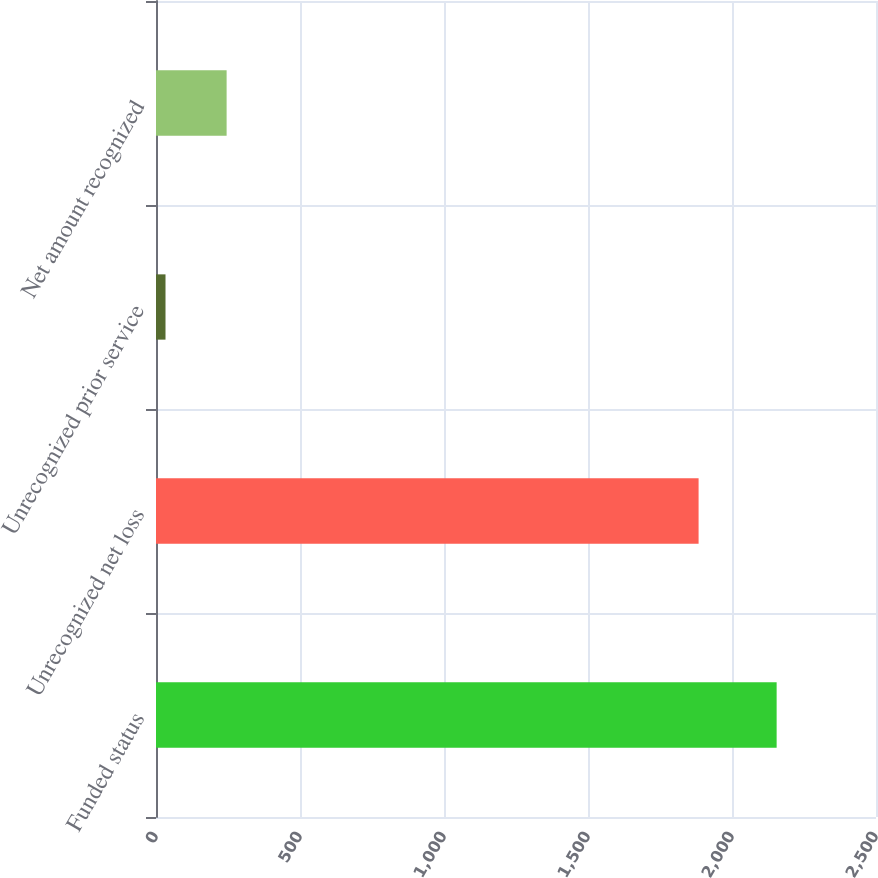Convert chart. <chart><loc_0><loc_0><loc_500><loc_500><bar_chart><fcel>Funded status<fcel>Unrecognized net loss<fcel>Unrecognized prior service<fcel>Net amount recognized<nl><fcel>2155<fcel>1884<fcel>33<fcel>245.2<nl></chart> 